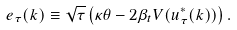Convert formula to latex. <formula><loc_0><loc_0><loc_500><loc_500>e _ { \tau } ( k ) \equiv \sqrt { \tau } \left ( \kappa \theta - 2 \beta _ { t } V ( u ^ { * } _ { \tau } ( k ) ) \right ) .</formula> 